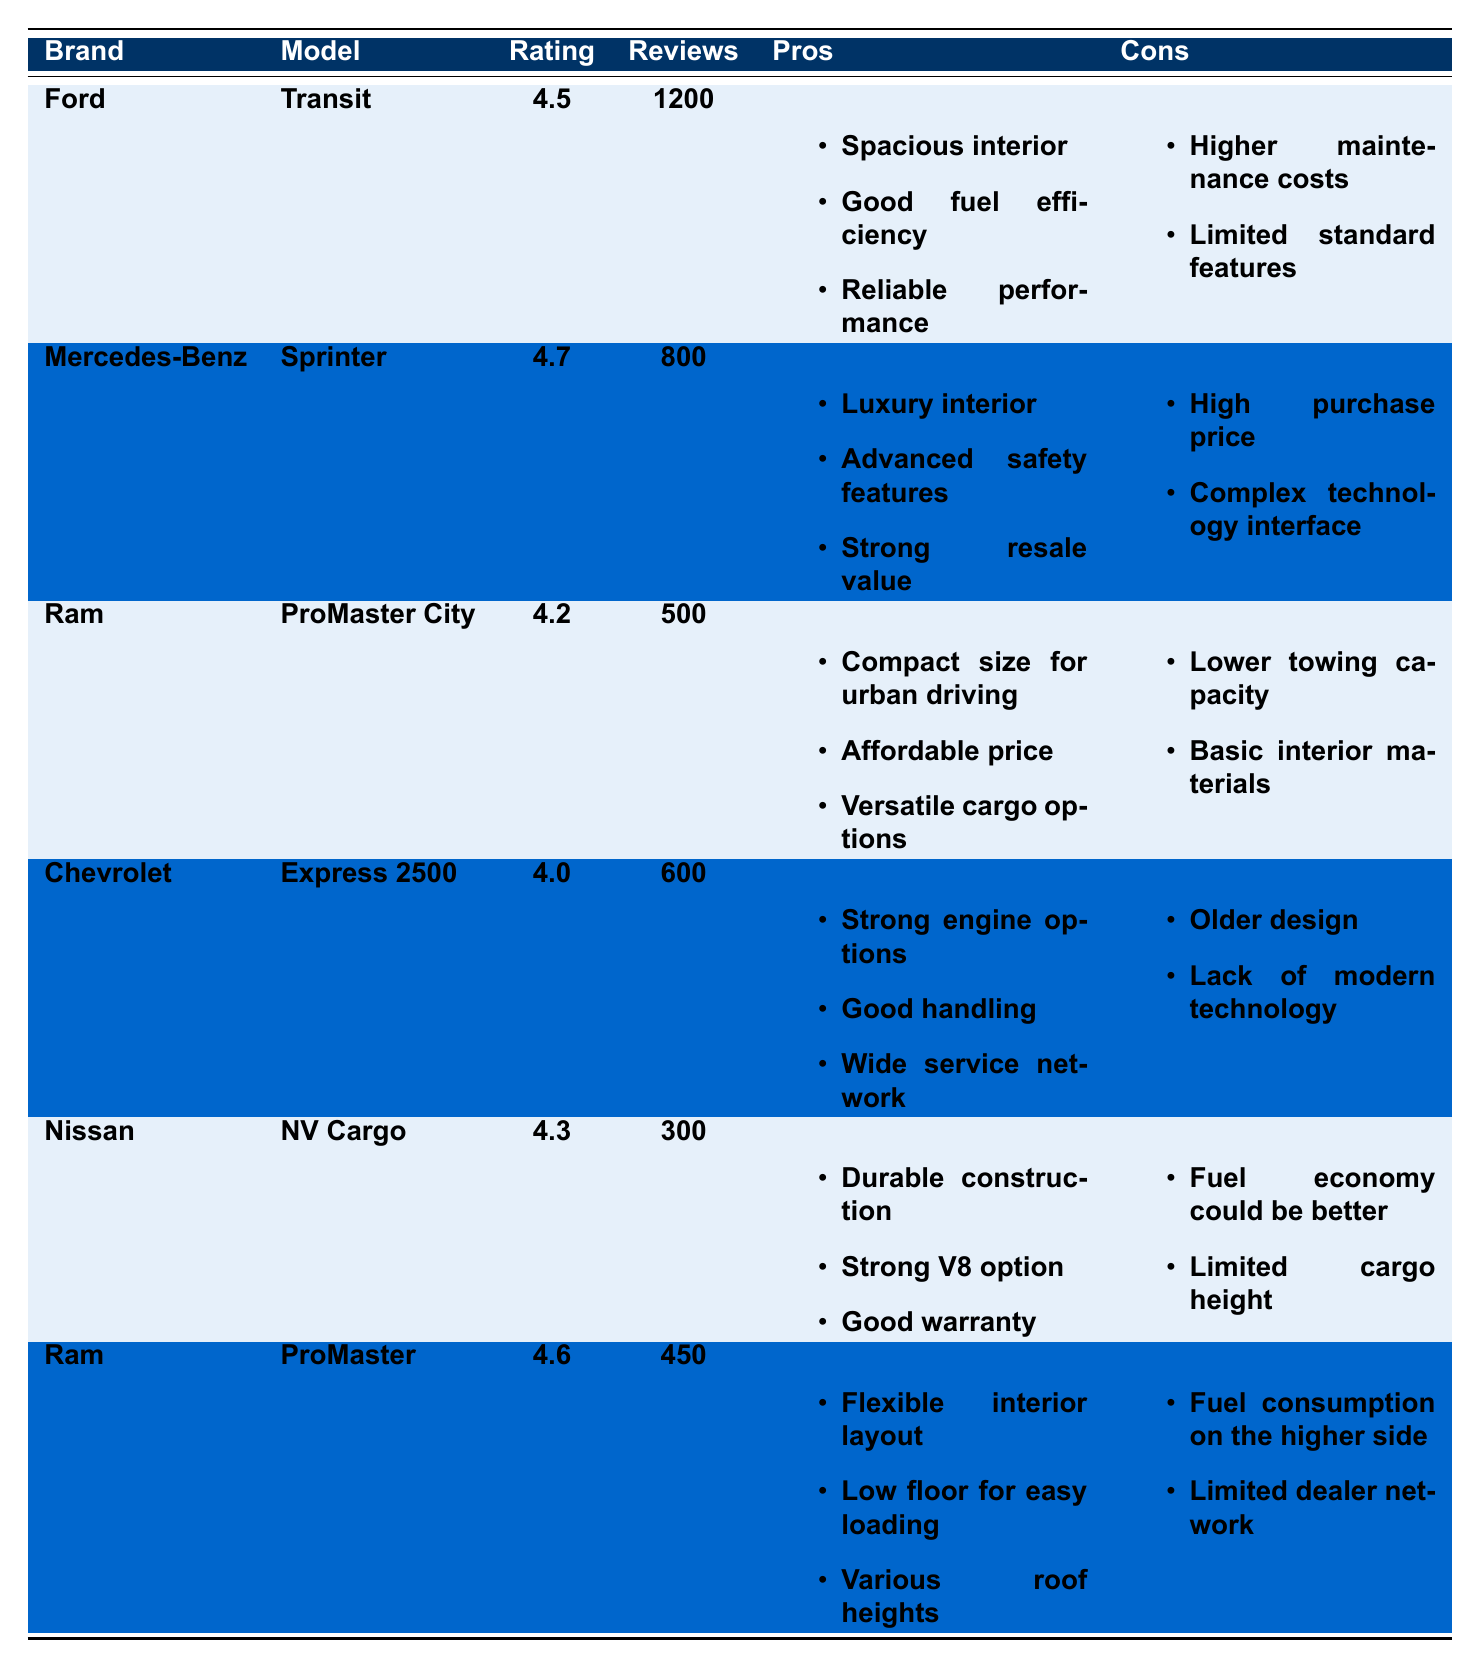What is the highest customer satisfaction rating among the commercial vans listed? The ratings for the vans are 4.5, 4.7, 4.2, 4.0, 4.3, and 4.6. The highest rating is 4.7 for the Mercedes-Benz Sprinter.
Answer: 4.7 How many reviews did the Ford Transit receive? The table specifies that the Ford Transit has a total of 1200 reviews.
Answer: 1200 Which van has the lowest number of reviews? The Nissan NV Cargo has the lowest number of reviews listed at 300.
Answer: 300 What are the pros of the Ram ProMaster? The Ram ProMaster has three listed pros: Flexible interior layout, Low floor for easy loading, and Various roof heights.
Answer: Flexible interior layout, Low floor for easy loading, Various roof heights Is the Chevrolet Express 2500 rated higher than the Ram ProMaster City? The Chevrolet Express 2500 has a rating of 4.0, while the Ram ProMaster City has a rating of 4.2. Therefore, it is rated lower than the Ram ProMaster City.
Answer: No Which van has strong resale value as a pro? The Mercedes-Benz Sprinter lists strong resale value as one of its pros.
Answer: Mercedes-Benz Sprinter What is the average customer satisfaction rating of the Ram vans? The Ram vans listed are the ProMaster City (4.2) and the ProMaster (4.6). The average rating is (4.2 + 4.6) / 2 = 4.4.
Answer: 4.4 Which van has the highest purchase price as a con? The Mercedes-Benz Sprinter has a high purchase price listed as a con.
Answer: Mercedes-Benz Sprinter What are the cons of the Nissan NV Cargo? The cons listed for the Nissan NV Cargo are: Fuel economy could be better and Limited cargo height.
Answer: Fuel economy could be better, Limited cargo height How many total reviews have been provided for all vans combined? The total number of reviews for all vans is calculated as 1200 (Ford) + 800 (Mercedes) + 500 (Ram ProMaster City) + 600 (Chevrolet) + 300 (Nissan) + 450 (Ram ProMaster) = 3850.
Answer: 3850 Which van has the most pros listed? The Mercedes-Benz Sprinter and the Ford Transit each have three pros listed, while all others have fewer. Thus, they tie for the most pros.
Answer: Mercedes-Benz Sprinter, Ford Transit 